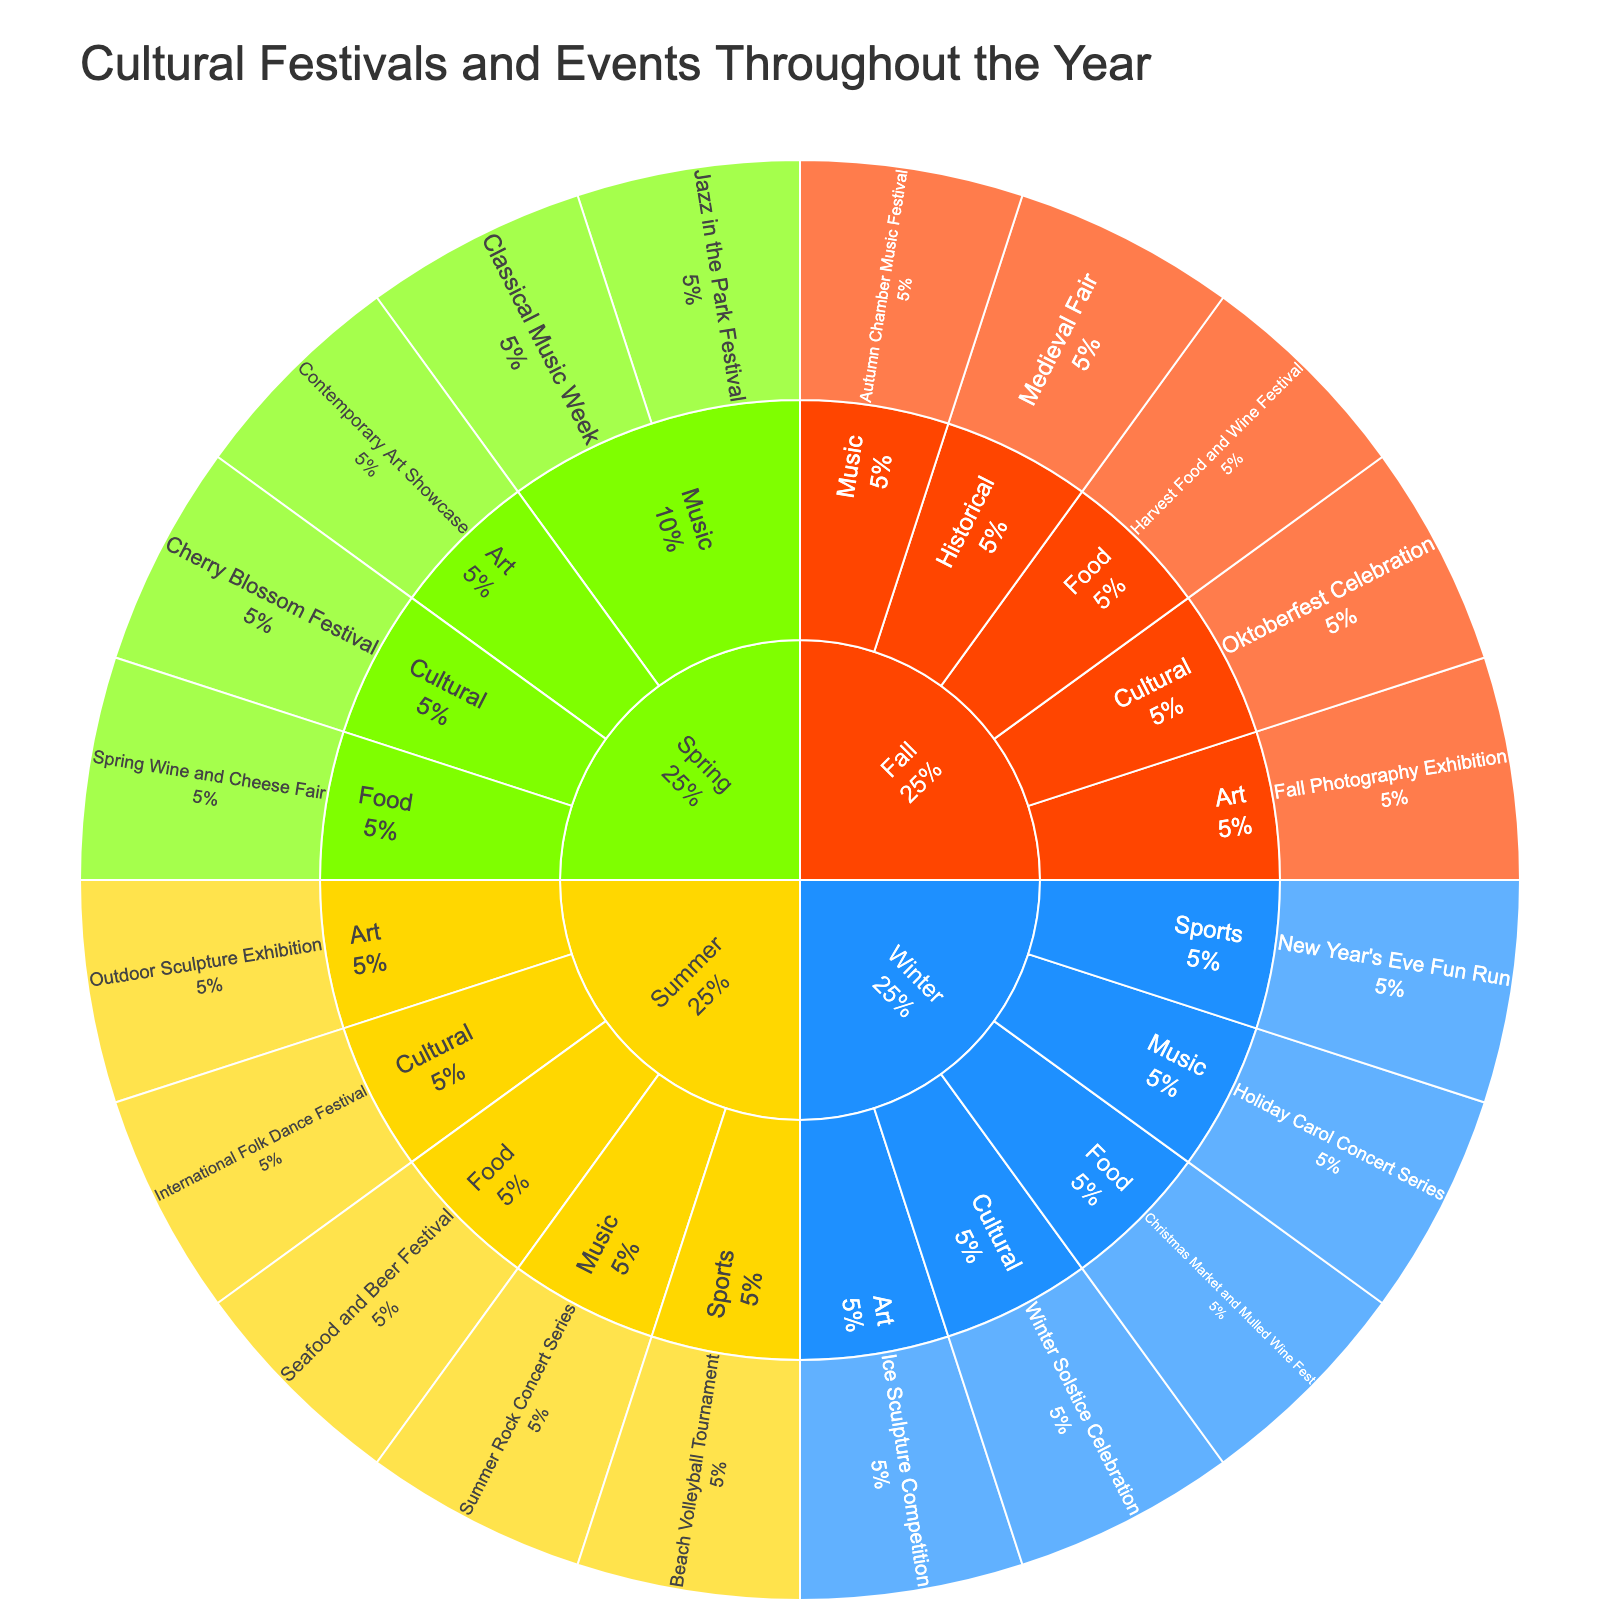What is the title of the plot? The title is usually positioned at the top of the plot. By examining the top part of the Sunburst Plot, we can identify the title.
Answer: Cultural Festivals and Events Throughout the Year How many themes are present in the Spring season? Look at the Spring section of the Sunburst Plot. Each distinct segment radiating from Spring represents a theme. Count these segments.
Answer: 4 Which season has the fewest events? Identify the outermost segments for each season. The season with the least number of outer segments has the fewest events.
Answer: Winter Which theme in Summer has the most events? Look at the Summer section and identify each theme present. Then, count the events under each theme. The theme with the highest count will be the answer.
Answer: Music How many cultural events are there in total? Identify all segments labeled "Cultural" across all seasons. Sum the number of events within each of these segments.
Answer: 4 Which season has the most diverse range of themes? Look at each season and count the number of distinct themes represented. The season with the highest number of different themes has the most diverse range.
Answer: Spring and Winter (tie) How many food-related events occur in Fall and Winter combined? Identify the "Food" theme within both Fall and Winter sections. Count the number of events in each and then sum these counts.
Answer: 2 Which season has the highest number of sports events? Identify which seasons contain sports events by looking for the "Sports" theme. Then, count the number of events within this theme for each season.
Answer: Winter How do the number of music events compare between Spring and Fall? Examine the "Music" theme for both Spring and Fall. Count the events in each and compare the totals.
Answer: Spring has more music events than Fall 